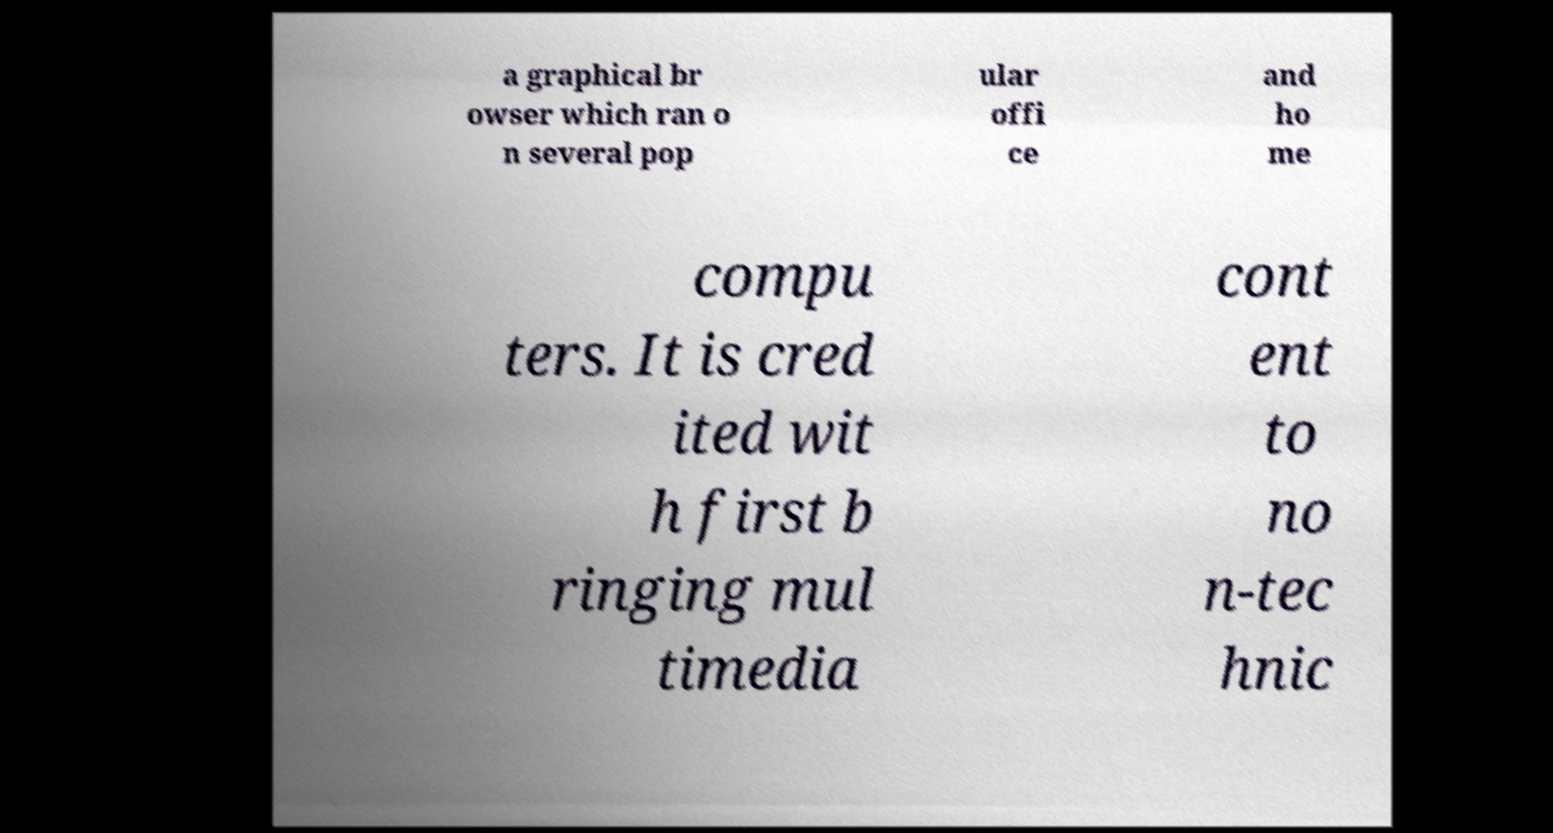Can you read and provide the text displayed in the image?This photo seems to have some interesting text. Can you extract and type it out for me? a graphical br owser which ran o n several pop ular offi ce and ho me compu ters. It is cred ited wit h first b ringing mul timedia cont ent to no n-tec hnic 